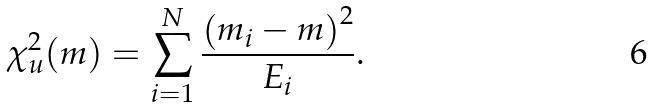<formula> <loc_0><loc_0><loc_500><loc_500>\chi _ { u } ^ { 2 } ( m ) = \sum _ { i = 1 } ^ { N } \frac { \left ( m _ { i } - m \right ) ^ { 2 } } { E _ { i } } .</formula> 